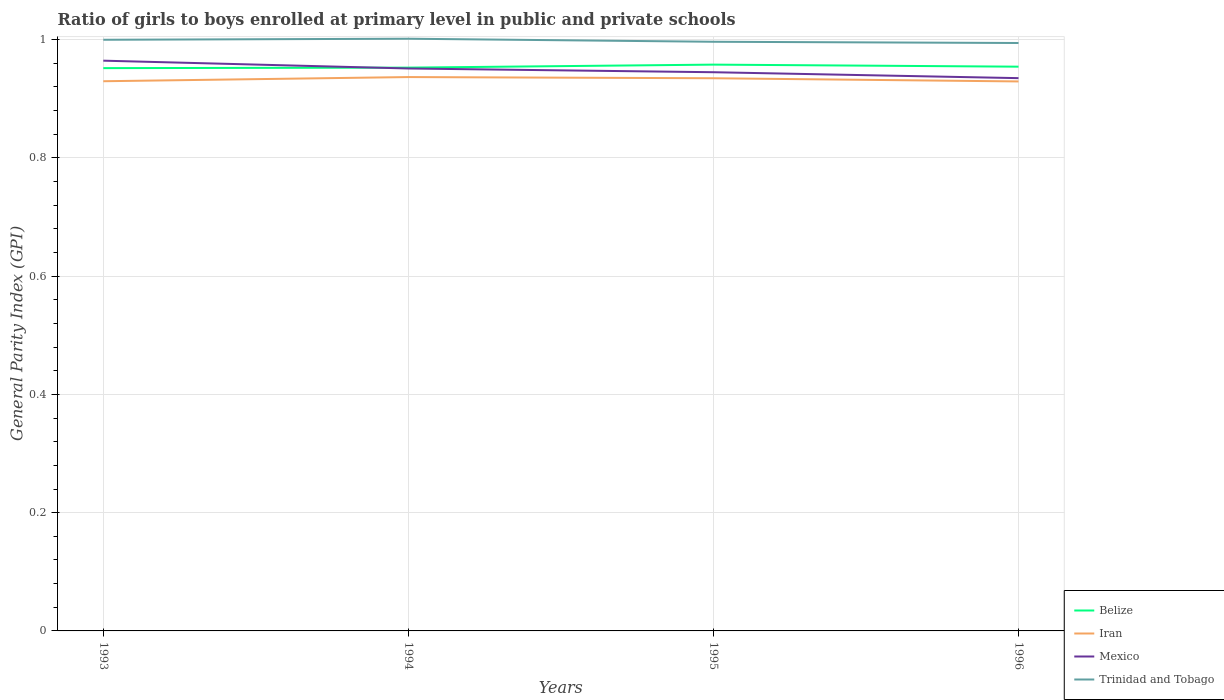How many different coloured lines are there?
Make the answer very short. 4. Across all years, what is the maximum general parity index in Belize?
Offer a terse response. 0.95. In which year was the general parity index in Iran maximum?
Offer a terse response. 1996. What is the total general parity index in Mexico in the graph?
Your answer should be compact. 0.02. What is the difference between the highest and the second highest general parity index in Trinidad and Tobago?
Ensure brevity in your answer.  0.01. Is the general parity index in Belize strictly greater than the general parity index in Trinidad and Tobago over the years?
Provide a succinct answer. Yes. How many lines are there?
Provide a succinct answer. 4. How many years are there in the graph?
Your response must be concise. 4. What is the difference between two consecutive major ticks on the Y-axis?
Your answer should be compact. 0.2. Does the graph contain grids?
Give a very brief answer. Yes. Where does the legend appear in the graph?
Your response must be concise. Bottom right. What is the title of the graph?
Ensure brevity in your answer.  Ratio of girls to boys enrolled at primary level in public and private schools. Does "Chile" appear as one of the legend labels in the graph?
Ensure brevity in your answer.  No. What is the label or title of the X-axis?
Your response must be concise. Years. What is the label or title of the Y-axis?
Provide a succinct answer. General Parity Index (GPI). What is the General Parity Index (GPI) in Belize in 1993?
Offer a terse response. 0.95. What is the General Parity Index (GPI) of Iran in 1993?
Make the answer very short. 0.93. What is the General Parity Index (GPI) in Mexico in 1993?
Your answer should be very brief. 0.96. What is the General Parity Index (GPI) in Trinidad and Tobago in 1993?
Your answer should be compact. 1. What is the General Parity Index (GPI) of Belize in 1994?
Your answer should be compact. 0.95. What is the General Parity Index (GPI) of Iran in 1994?
Keep it short and to the point. 0.94. What is the General Parity Index (GPI) of Mexico in 1994?
Provide a short and direct response. 0.95. What is the General Parity Index (GPI) in Trinidad and Tobago in 1994?
Your answer should be very brief. 1. What is the General Parity Index (GPI) of Belize in 1995?
Make the answer very short. 0.96. What is the General Parity Index (GPI) in Iran in 1995?
Offer a very short reply. 0.93. What is the General Parity Index (GPI) of Mexico in 1995?
Give a very brief answer. 0.94. What is the General Parity Index (GPI) of Trinidad and Tobago in 1995?
Your response must be concise. 1. What is the General Parity Index (GPI) of Belize in 1996?
Make the answer very short. 0.95. What is the General Parity Index (GPI) of Iran in 1996?
Your response must be concise. 0.93. What is the General Parity Index (GPI) in Mexico in 1996?
Your answer should be very brief. 0.93. What is the General Parity Index (GPI) of Trinidad and Tobago in 1996?
Offer a terse response. 0.99. Across all years, what is the maximum General Parity Index (GPI) in Belize?
Provide a short and direct response. 0.96. Across all years, what is the maximum General Parity Index (GPI) of Iran?
Your answer should be compact. 0.94. Across all years, what is the maximum General Parity Index (GPI) in Mexico?
Make the answer very short. 0.96. Across all years, what is the maximum General Parity Index (GPI) in Trinidad and Tobago?
Offer a very short reply. 1. Across all years, what is the minimum General Parity Index (GPI) in Belize?
Your answer should be very brief. 0.95. Across all years, what is the minimum General Parity Index (GPI) in Iran?
Make the answer very short. 0.93. Across all years, what is the minimum General Parity Index (GPI) in Mexico?
Offer a very short reply. 0.93. Across all years, what is the minimum General Parity Index (GPI) of Trinidad and Tobago?
Make the answer very short. 0.99. What is the total General Parity Index (GPI) of Belize in the graph?
Your response must be concise. 3.82. What is the total General Parity Index (GPI) of Iran in the graph?
Offer a very short reply. 3.73. What is the total General Parity Index (GPI) in Mexico in the graph?
Your response must be concise. 3.8. What is the total General Parity Index (GPI) of Trinidad and Tobago in the graph?
Your answer should be compact. 3.99. What is the difference between the General Parity Index (GPI) in Belize in 1993 and that in 1994?
Offer a terse response. -0. What is the difference between the General Parity Index (GPI) of Iran in 1993 and that in 1994?
Make the answer very short. -0.01. What is the difference between the General Parity Index (GPI) in Mexico in 1993 and that in 1994?
Keep it short and to the point. 0.01. What is the difference between the General Parity Index (GPI) in Trinidad and Tobago in 1993 and that in 1994?
Provide a succinct answer. -0. What is the difference between the General Parity Index (GPI) of Belize in 1993 and that in 1995?
Your answer should be very brief. -0.01. What is the difference between the General Parity Index (GPI) of Iran in 1993 and that in 1995?
Provide a succinct answer. -0.01. What is the difference between the General Parity Index (GPI) of Mexico in 1993 and that in 1995?
Give a very brief answer. 0.02. What is the difference between the General Parity Index (GPI) in Trinidad and Tobago in 1993 and that in 1995?
Your answer should be compact. 0. What is the difference between the General Parity Index (GPI) of Belize in 1993 and that in 1996?
Provide a short and direct response. -0. What is the difference between the General Parity Index (GPI) of Iran in 1993 and that in 1996?
Offer a terse response. 0. What is the difference between the General Parity Index (GPI) of Mexico in 1993 and that in 1996?
Provide a short and direct response. 0.03. What is the difference between the General Parity Index (GPI) of Trinidad and Tobago in 1993 and that in 1996?
Provide a succinct answer. 0.01. What is the difference between the General Parity Index (GPI) in Belize in 1994 and that in 1995?
Give a very brief answer. -0.01. What is the difference between the General Parity Index (GPI) in Iran in 1994 and that in 1995?
Keep it short and to the point. 0. What is the difference between the General Parity Index (GPI) of Mexico in 1994 and that in 1995?
Provide a short and direct response. 0.01. What is the difference between the General Parity Index (GPI) in Trinidad and Tobago in 1994 and that in 1995?
Provide a succinct answer. 0.01. What is the difference between the General Parity Index (GPI) of Belize in 1994 and that in 1996?
Your answer should be compact. -0. What is the difference between the General Parity Index (GPI) of Iran in 1994 and that in 1996?
Your response must be concise. 0.01. What is the difference between the General Parity Index (GPI) in Mexico in 1994 and that in 1996?
Your answer should be very brief. 0.02. What is the difference between the General Parity Index (GPI) of Trinidad and Tobago in 1994 and that in 1996?
Provide a short and direct response. 0.01. What is the difference between the General Parity Index (GPI) in Belize in 1995 and that in 1996?
Keep it short and to the point. 0. What is the difference between the General Parity Index (GPI) in Iran in 1995 and that in 1996?
Make the answer very short. 0.01. What is the difference between the General Parity Index (GPI) in Trinidad and Tobago in 1995 and that in 1996?
Make the answer very short. 0. What is the difference between the General Parity Index (GPI) in Belize in 1993 and the General Parity Index (GPI) in Iran in 1994?
Make the answer very short. 0.02. What is the difference between the General Parity Index (GPI) in Belize in 1993 and the General Parity Index (GPI) in Mexico in 1994?
Your response must be concise. 0. What is the difference between the General Parity Index (GPI) in Belize in 1993 and the General Parity Index (GPI) in Trinidad and Tobago in 1994?
Keep it short and to the point. -0.05. What is the difference between the General Parity Index (GPI) in Iran in 1993 and the General Parity Index (GPI) in Mexico in 1994?
Offer a terse response. -0.02. What is the difference between the General Parity Index (GPI) in Iran in 1993 and the General Parity Index (GPI) in Trinidad and Tobago in 1994?
Offer a very short reply. -0.07. What is the difference between the General Parity Index (GPI) in Mexico in 1993 and the General Parity Index (GPI) in Trinidad and Tobago in 1994?
Give a very brief answer. -0.04. What is the difference between the General Parity Index (GPI) of Belize in 1993 and the General Parity Index (GPI) of Iran in 1995?
Provide a succinct answer. 0.02. What is the difference between the General Parity Index (GPI) of Belize in 1993 and the General Parity Index (GPI) of Mexico in 1995?
Keep it short and to the point. 0.01. What is the difference between the General Parity Index (GPI) of Belize in 1993 and the General Parity Index (GPI) of Trinidad and Tobago in 1995?
Make the answer very short. -0.04. What is the difference between the General Parity Index (GPI) of Iran in 1993 and the General Parity Index (GPI) of Mexico in 1995?
Your answer should be very brief. -0.02. What is the difference between the General Parity Index (GPI) in Iran in 1993 and the General Parity Index (GPI) in Trinidad and Tobago in 1995?
Your answer should be compact. -0.07. What is the difference between the General Parity Index (GPI) in Mexico in 1993 and the General Parity Index (GPI) in Trinidad and Tobago in 1995?
Provide a succinct answer. -0.03. What is the difference between the General Parity Index (GPI) of Belize in 1993 and the General Parity Index (GPI) of Iran in 1996?
Provide a short and direct response. 0.02. What is the difference between the General Parity Index (GPI) in Belize in 1993 and the General Parity Index (GPI) in Mexico in 1996?
Provide a succinct answer. 0.02. What is the difference between the General Parity Index (GPI) of Belize in 1993 and the General Parity Index (GPI) of Trinidad and Tobago in 1996?
Your answer should be compact. -0.04. What is the difference between the General Parity Index (GPI) of Iran in 1993 and the General Parity Index (GPI) of Mexico in 1996?
Your answer should be compact. -0.01. What is the difference between the General Parity Index (GPI) in Iran in 1993 and the General Parity Index (GPI) in Trinidad and Tobago in 1996?
Offer a very short reply. -0.06. What is the difference between the General Parity Index (GPI) of Mexico in 1993 and the General Parity Index (GPI) of Trinidad and Tobago in 1996?
Offer a terse response. -0.03. What is the difference between the General Parity Index (GPI) in Belize in 1994 and the General Parity Index (GPI) in Iran in 1995?
Offer a very short reply. 0.02. What is the difference between the General Parity Index (GPI) in Belize in 1994 and the General Parity Index (GPI) in Mexico in 1995?
Your answer should be very brief. 0.01. What is the difference between the General Parity Index (GPI) of Belize in 1994 and the General Parity Index (GPI) of Trinidad and Tobago in 1995?
Make the answer very short. -0.04. What is the difference between the General Parity Index (GPI) of Iran in 1994 and the General Parity Index (GPI) of Mexico in 1995?
Your answer should be very brief. -0.01. What is the difference between the General Parity Index (GPI) of Iran in 1994 and the General Parity Index (GPI) of Trinidad and Tobago in 1995?
Offer a terse response. -0.06. What is the difference between the General Parity Index (GPI) of Mexico in 1994 and the General Parity Index (GPI) of Trinidad and Tobago in 1995?
Offer a terse response. -0.05. What is the difference between the General Parity Index (GPI) in Belize in 1994 and the General Parity Index (GPI) in Iran in 1996?
Ensure brevity in your answer.  0.02. What is the difference between the General Parity Index (GPI) of Belize in 1994 and the General Parity Index (GPI) of Mexico in 1996?
Provide a short and direct response. 0.02. What is the difference between the General Parity Index (GPI) in Belize in 1994 and the General Parity Index (GPI) in Trinidad and Tobago in 1996?
Provide a short and direct response. -0.04. What is the difference between the General Parity Index (GPI) in Iran in 1994 and the General Parity Index (GPI) in Mexico in 1996?
Your response must be concise. 0. What is the difference between the General Parity Index (GPI) of Iran in 1994 and the General Parity Index (GPI) of Trinidad and Tobago in 1996?
Provide a short and direct response. -0.06. What is the difference between the General Parity Index (GPI) in Mexico in 1994 and the General Parity Index (GPI) in Trinidad and Tobago in 1996?
Offer a very short reply. -0.04. What is the difference between the General Parity Index (GPI) of Belize in 1995 and the General Parity Index (GPI) of Iran in 1996?
Offer a terse response. 0.03. What is the difference between the General Parity Index (GPI) in Belize in 1995 and the General Parity Index (GPI) in Mexico in 1996?
Keep it short and to the point. 0.02. What is the difference between the General Parity Index (GPI) of Belize in 1995 and the General Parity Index (GPI) of Trinidad and Tobago in 1996?
Provide a short and direct response. -0.04. What is the difference between the General Parity Index (GPI) of Iran in 1995 and the General Parity Index (GPI) of Mexico in 1996?
Offer a very short reply. -0. What is the difference between the General Parity Index (GPI) in Iran in 1995 and the General Parity Index (GPI) in Trinidad and Tobago in 1996?
Offer a very short reply. -0.06. What is the difference between the General Parity Index (GPI) in Mexico in 1995 and the General Parity Index (GPI) in Trinidad and Tobago in 1996?
Give a very brief answer. -0.05. What is the average General Parity Index (GPI) in Belize per year?
Your answer should be very brief. 0.95. What is the average General Parity Index (GPI) in Iran per year?
Provide a short and direct response. 0.93. What is the average General Parity Index (GPI) of Mexico per year?
Offer a very short reply. 0.95. What is the average General Parity Index (GPI) in Trinidad and Tobago per year?
Offer a terse response. 1. In the year 1993, what is the difference between the General Parity Index (GPI) in Belize and General Parity Index (GPI) in Iran?
Your response must be concise. 0.02. In the year 1993, what is the difference between the General Parity Index (GPI) of Belize and General Parity Index (GPI) of Mexico?
Keep it short and to the point. -0.01. In the year 1993, what is the difference between the General Parity Index (GPI) of Belize and General Parity Index (GPI) of Trinidad and Tobago?
Offer a terse response. -0.05. In the year 1993, what is the difference between the General Parity Index (GPI) in Iran and General Parity Index (GPI) in Mexico?
Ensure brevity in your answer.  -0.03. In the year 1993, what is the difference between the General Parity Index (GPI) of Iran and General Parity Index (GPI) of Trinidad and Tobago?
Offer a very short reply. -0.07. In the year 1993, what is the difference between the General Parity Index (GPI) in Mexico and General Parity Index (GPI) in Trinidad and Tobago?
Provide a succinct answer. -0.04. In the year 1994, what is the difference between the General Parity Index (GPI) of Belize and General Parity Index (GPI) of Iran?
Provide a short and direct response. 0.02. In the year 1994, what is the difference between the General Parity Index (GPI) in Belize and General Parity Index (GPI) in Mexico?
Ensure brevity in your answer.  0. In the year 1994, what is the difference between the General Parity Index (GPI) of Belize and General Parity Index (GPI) of Trinidad and Tobago?
Ensure brevity in your answer.  -0.05. In the year 1994, what is the difference between the General Parity Index (GPI) of Iran and General Parity Index (GPI) of Mexico?
Make the answer very short. -0.01. In the year 1994, what is the difference between the General Parity Index (GPI) of Iran and General Parity Index (GPI) of Trinidad and Tobago?
Provide a succinct answer. -0.06. In the year 1994, what is the difference between the General Parity Index (GPI) in Mexico and General Parity Index (GPI) in Trinidad and Tobago?
Your answer should be very brief. -0.05. In the year 1995, what is the difference between the General Parity Index (GPI) in Belize and General Parity Index (GPI) in Iran?
Offer a very short reply. 0.02. In the year 1995, what is the difference between the General Parity Index (GPI) in Belize and General Parity Index (GPI) in Mexico?
Your answer should be compact. 0.01. In the year 1995, what is the difference between the General Parity Index (GPI) of Belize and General Parity Index (GPI) of Trinidad and Tobago?
Your answer should be very brief. -0.04. In the year 1995, what is the difference between the General Parity Index (GPI) of Iran and General Parity Index (GPI) of Mexico?
Your response must be concise. -0.01. In the year 1995, what is the difference between the General Parity Index (GPI) of Iran and General Parity Index (GPI) of Trinidad and Tobago?
Keep it short and to the point. -0.06. In the year 1995, what is the difference between the General Parity Index (GPI) of Mexico and General Parity Index (GPI) of Trinidad and Tobago?
Your answer should be compact. -0.05. In the year 1996, what is the difference between the General Parity Index (GPI) of Belize and General Parity Index (GPI) of Iran?
Provide a short and direct response. 0.03. In the year 1996, what is the difference between the General Parity Index (GPI) of Belize and General Parity Index (GPI) of Mexico?
Provide a short and direct response. 0.02. In the year 1996, what is the difference between the General Parity Index (GPI) of Belize and General Parity Index (GPI) of Trinidad and Tobago?
Offer a very short reply. -0.04. In the year 1996, what is the difference between the General Parity Index (GPI) in Iran and General Parity Index (GPI) in Mexico?
Offer a terse response. -0.01. In the year 1996, what is the difference between the General Parity Index (GPI) in Iran and General Parity Index (GPI) in Trinidad and Tobago?
Give a very brief answer. -0.07. In the year 1996, what is the difference between the General Parity Index (GPI) in Mexico and General Parity Index (GPI) in Trinidad and Tobago?
Ensure brevity in your answer.  -0.06. What is the ratio of the General Parity Index (GPI) of Mexico in 1993 to that in 1994?
Keep it short and to the point. 1.01. What is the ratio of the General Parity Index (GPI) of Trinidad and Tobago in 1993 to that in 1994?
Ensure brevity in your answer.  1. What is the ratio of the General Parity Index (GPI) in Iran in 1993 to that in 1995?
Ensure brevity in your answer.  0.99. What is the ratio of the General Parity Index (GPI) in Mexico in 1993 to that in 1995?
Your answer should be very brief. 1.02. What is the ratio of the General Parity Index (GPI) in Trinidad and Tobago in 1993 to that in 1995?
Provide a short and direct response. 1. What is the ratio of the General Parity Index (GPI) of Mexico in 1993 to that in 1996?
Keep it short and to the point. 1.03. What is the ratio of the General Parity Index (GPI) of Iran in 1994 to that in 1995?
Offer a very short reply. 1. What is the ratio of the General Parity Index (GPI) in Mexico in 1994 to that in 1995?
Offer a very short reply. 1.01. What is the ratio of the General Parity Index (GPI) in Trinidad and Tobago in 1994 to that in 1995?
Keep it short and to the point. 1.01. What is the ratio of the General Parity Index (GPI) in Mexico in 1994 to that in 1996?
Provide a short and direct response. 1.02. What is the ratio of the General Parity Index (GPI) in Trinidad and Tobago in 1994 to that in 1996?
Make the answer very short. 1.01. What is the ratio of the General Parity Index (GPI) in Belize in 1995 to that in 1996?
Give a very brief answer. 1. What is the ratio of the General Parity Index (GPI) in Mexico in 1995 to that in 1996?
Offer a terse response. 1.01. What is the ratio of the General Parity Index (GPI) in Trinidad and Tobago in 1995 to that in 1996?
Keep it short and to the point. 1. What is the difference between the highest and the second highest General Parity Index (GPI) in Belize?
Your response must be concise. 0. What is the difference between the highest and the second highest General Parity Index (GPI) in Iran?
Offer a very short reply. 0. What is the difference between the highest and the second highest General Parity Index (GPI) in Mexico?
Your response must be concise. 0.01. What is the difference between the highest and the second highest General Parity Index (GPI) in Trinidad and Tobago?
Make the answer very short. 0. What is the difference between the highest and the lowest General Parity Index (GPI) of Belize?
Your answer should be compact. 0.01. What is the difference between the highest and the lowest General Parity Index (GPI) of Iran?
Your response must be concise. 0.01. What is the difference between the highest and the lowest General Parity Index (GPI) in Mexico?
Provide a short and direct response. 0.03. What is the difference between the highest and the lowest General Parity Index (GPI) in Trinidad and Tobago?
Your answer should be very brief. 0.01. 